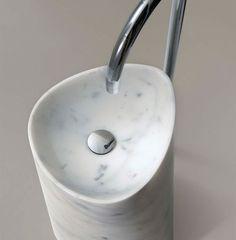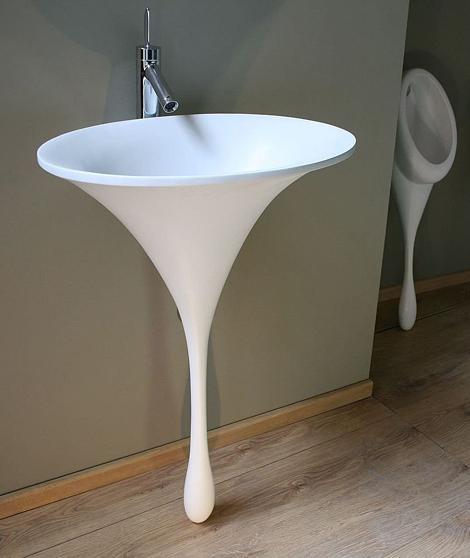The first image is the image on the left, the second image is the image on the right. Assess this claim about the two images: "Each sink is rounded, white, sits atop a counter, and has the spout and faucet mounted on the wall above it.". Correct or not? Answer yes or no. No. The first image is the image on the left, the second image is the image on the right. Evaluate the accuracy of this statement regarding the images: "One white sink is round and one is oval, neither directly attached to a chrome spout fixture that overhangs it.". Is it true? Answer yes or no. No. 